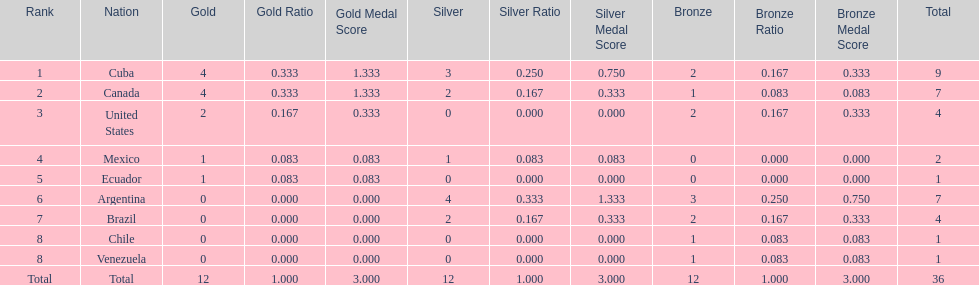Parse the table in full. {'header': ['Rank', 'Nation', 'Gold', 'Gold Ratio', 'Gold Medal Score', 'Silver', 'Silver Ratio', 'Silver Medal Score', 'Bronze', 'Bronze Ratio', 'Bronze Medal Score', 'Total'], 'rows': [['1', 'Cuba', '4', '0.333', '1.333', '3', '0.250', '0.750', '2', '0.167', '0.333', '9'], ['2', 'Canada', '4', '0.333', '1.333', '2', '0.167', '0.333', '1', '0.083', '0.083', '7'], ['3', 'United States', '2', '0.167', '0.333', '0', '0.000', '0.000', '2', '0.167', '0.333', '4'], ['4', 'Mexico', '1', '0.083', '0.083', '1', '0.083', '0.083', '0', '0.000', '0.000', '2'], ['5', 'Ecuador', '1', '0.083', '0.083', '0', '0.000', '0.000', '0', '0.000', '0.000', '1'], ['6', 'Argentina', '0', '0.000', '0.000', '4', '0.333', '1.333', '3', '0.250', '0.750', '7'], ['7', 'Brazil', '0', '0.000', '0.000', '2', '0.167', '0.333', '2', '0.167', '0.333', '4'], ['8', 'Chile', '0', '0.000', '0.000', '0', '0.000', '0.000', '1', '0.083', '0.083', '1'], ['8', 'Venezuela', '0', '0.000', '0.000', '0', '0.000', '0.000', '1', '0.083', '0.083', '1'], ['Total', 'Total', '12', '1.000', '3.000', '12', '1.000', '3.000', '12', '1.000', '3.000', '36']]} Who had more silver medals, cuba or brazil? Cuba. 